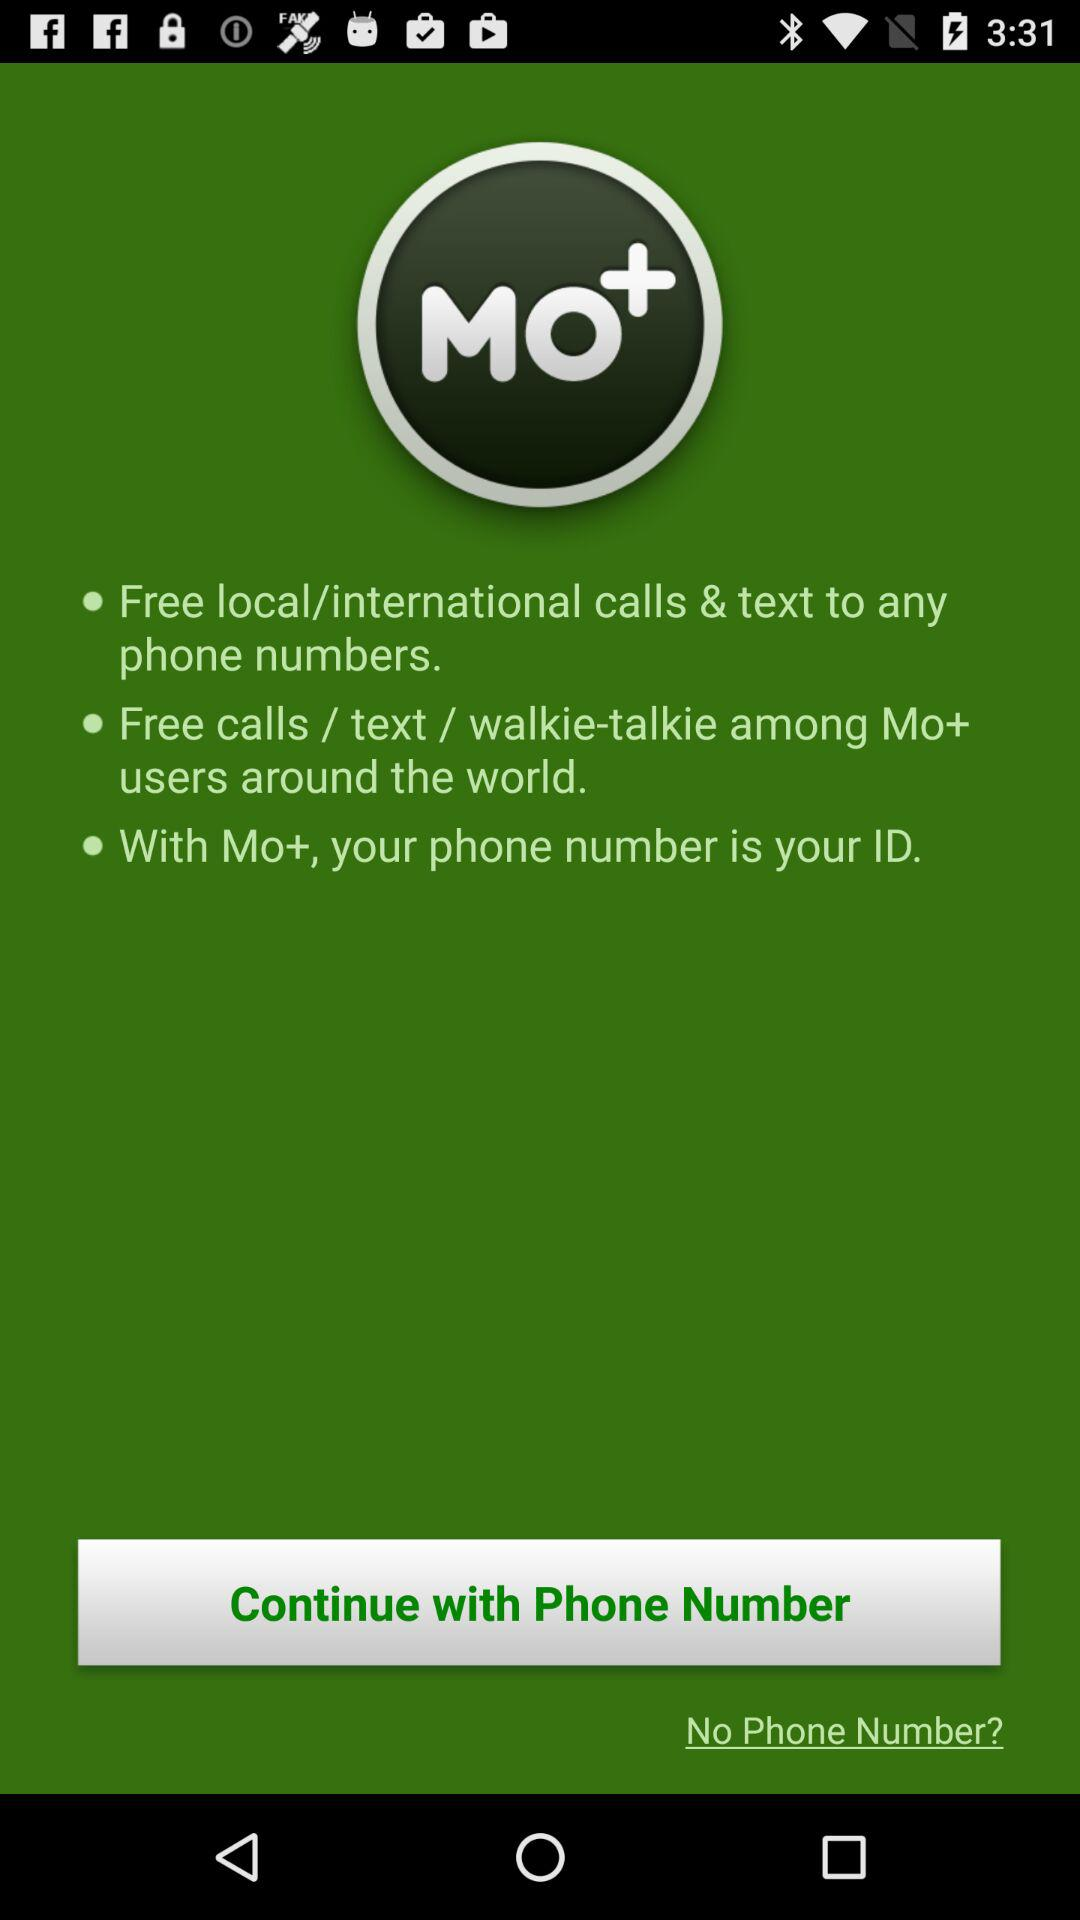What is the phone number?
When the provided information is insufficient, respond with <no answer>. <no answer> 